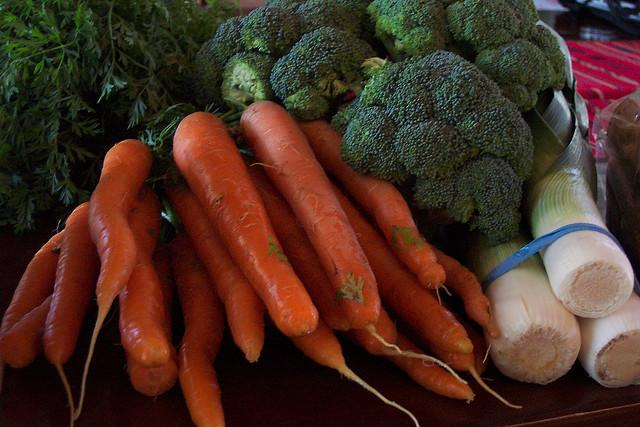What is a collective name given to the food options above? Please explain your reasoning. veggies. All of these produce options are called vegetables. 